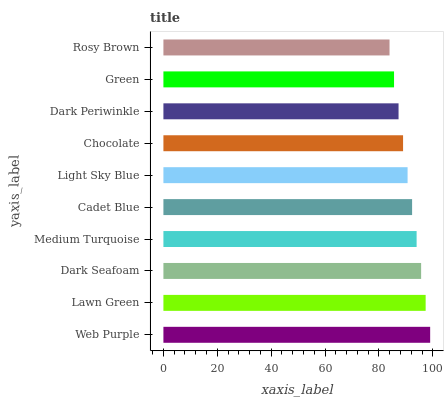Is Rosy Brown the minimum?
Answer yes or no. Yes. Is Web Purple the maximum?
Answer yes or no. Yes. Is Lawn Green the minimum?
Answer yes or no. No. Is Lawn Green the maximum?
Answer yes or no. No. Is Web Purple greater than Lawn Green?
Answer yes or no. Yes. Is Lawn Green less than Web Purple?
Answer yes or no. Yes. Is Lawn Green greater than Web Purple?
Answer yes or no. No. Is Web Purple less than Lawn Green?
Answer yes or no. No. Is Cadet Blue the high median?
Answer yes or no. Yes. Is Light Sky Blue the low median?
Answer yes or no. Yes. Is Lawn Green the high median?
Answer yes or no. No. Is Dark Seafoam the low median?
Answer yes or no. No. 